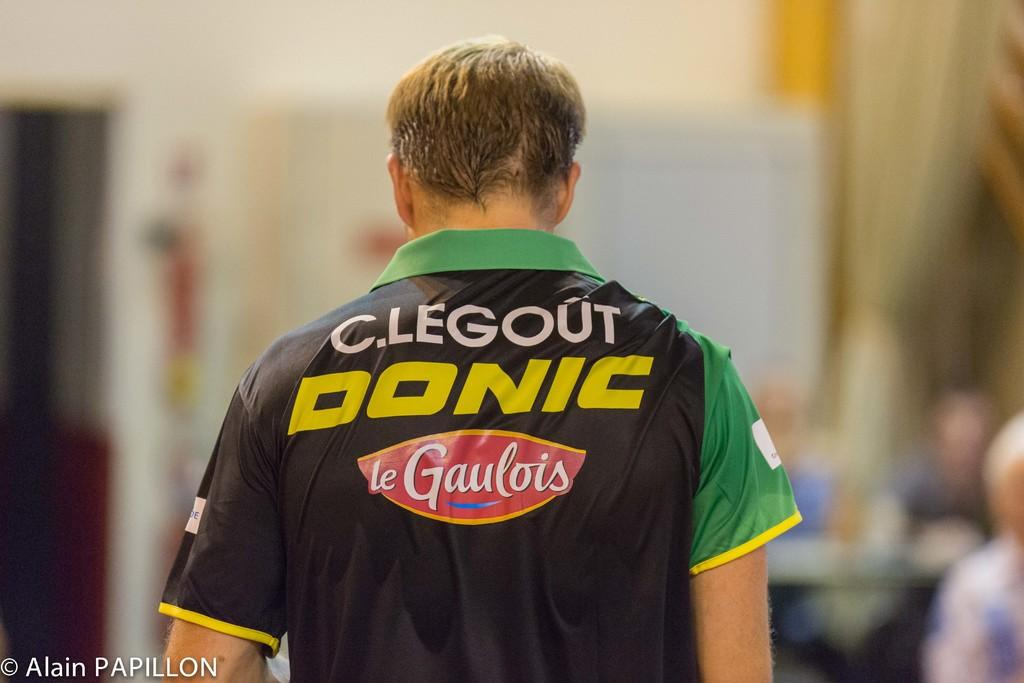<image>
Relay a brief, clear account of the picture shown. The back of a man with short brown hair whose shirt says C.Legout Donic le Gaulois. 